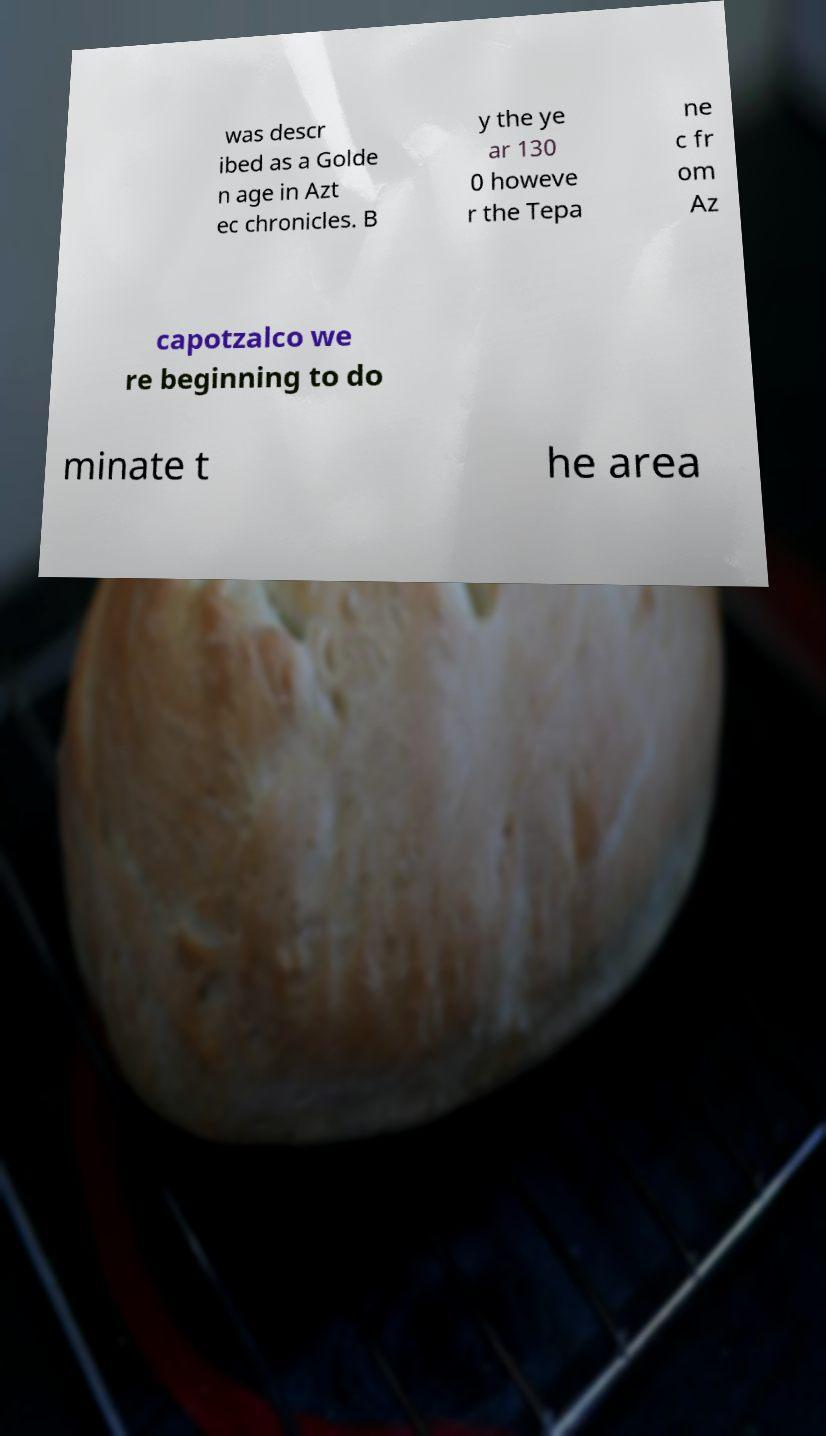Could you extract and type out the text from this image? was descr ibed as a Golde n age in Azt ec chronicles. B y the ye ar 130 0 howeve r the Tepa ne c fr om Az capotzalco we re beginning to do minate t he area 